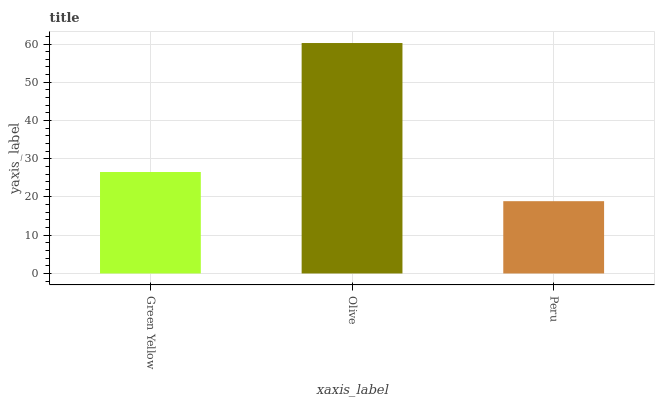Is Peru the minimum?
Answer yes or no. Yes. Is Olive the maximum?
Answer yes or no. Yes. Is Olive the minimum?
Answer yes or no. No. Is Peru the maximum?
Answer yes or no. No. Is Olive greater than Peru?
Answer yes or no. Yes. Is Peru less than Olive?
Answer yes or no. Yes. Is Peru greater than Olive?
Answer yes or no. No. Is Olive less than Peru?
Answer yes or no. No. Is Green Yellow the high median?
Answer yes or no. Yes. Is Green Yellow the low median?
Answer yes or no. Yes. Is Olive the high median?
Answer yes or no. No. Is Olive the low median?
Answer yes or no. No. 